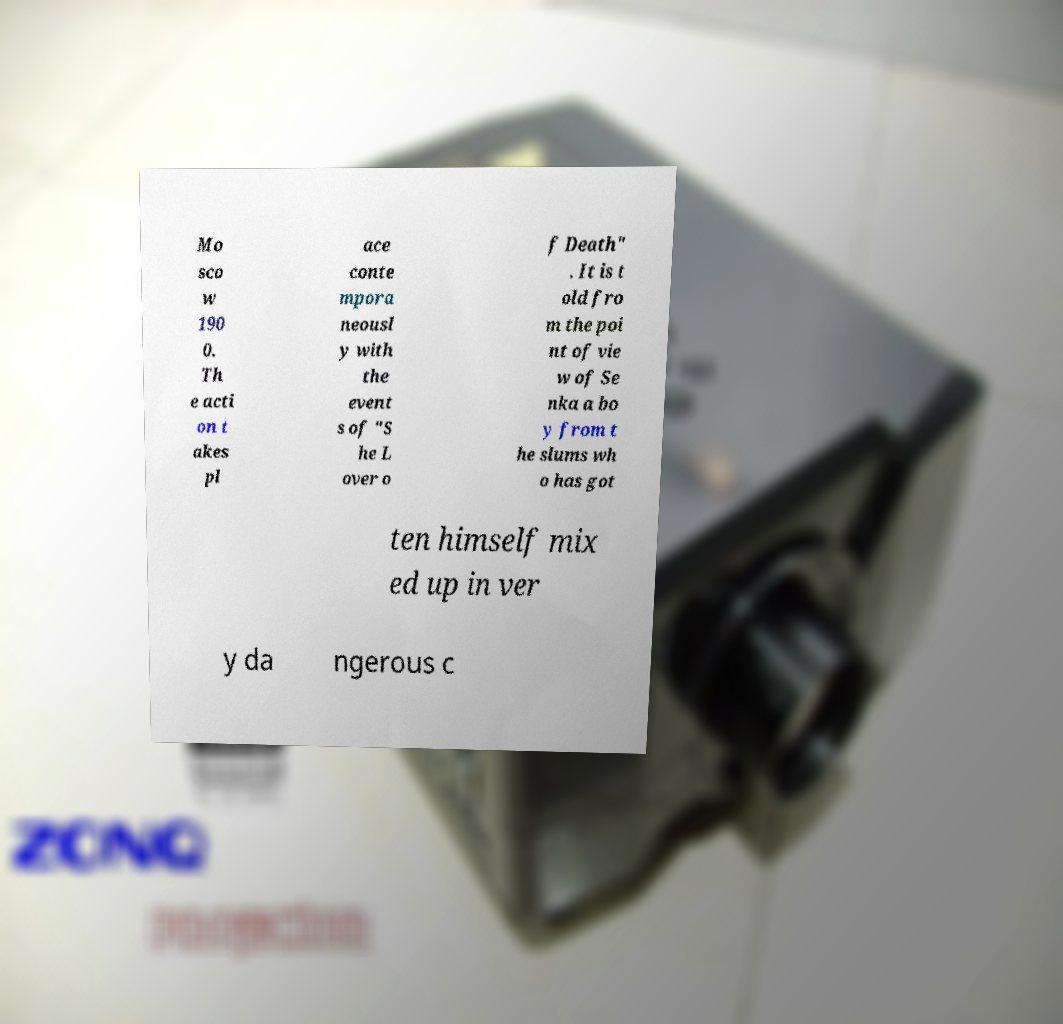Please identify and transcribe the text found in this image. Mo sco w 190 0. Th e acti on t akes pl ace conte mpora neousl y with the event s of "S he L over o f Death" . It is t old fro m the poi nt of vie w of Se nka a bo y from t he slums wh o has got ten himself mix ed up in ver y da ngerous c 